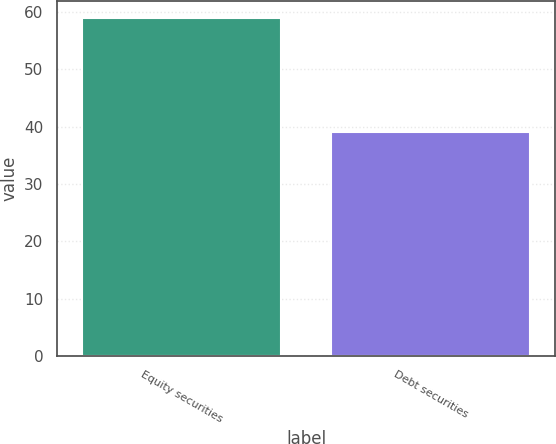Convert chart to OTSL. <chart><loc_0><loc_0><loc_500><loc_500><bar_chart><fcel>Equity securities<fcel>Debt securities<nl><fcel>59<fcel>39<nl></chart> 